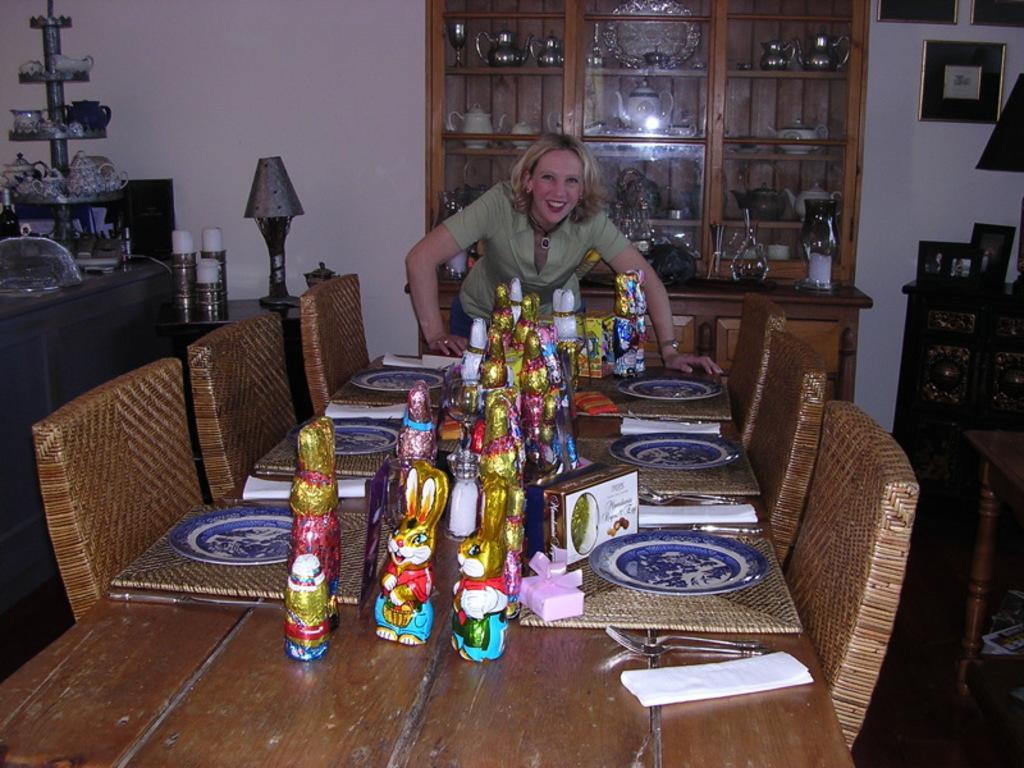Could you give a brief overview of what you see in this image? In this image we can see a woman standing near the table. There are many things placed on the table. We can see chairs, cupboards with something's in it, lamp and photo frames on the wall. 